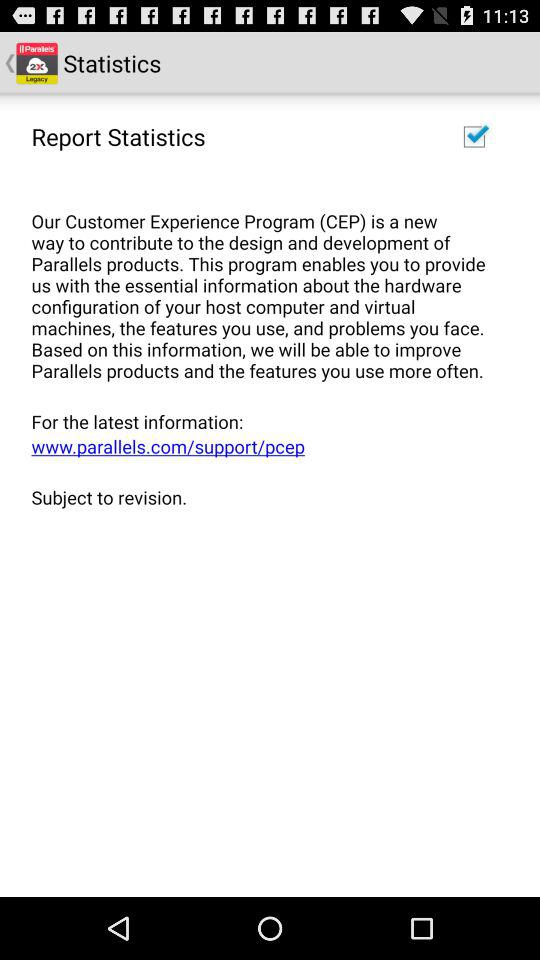What is the status of "Report Statistics"? The status is "on". 